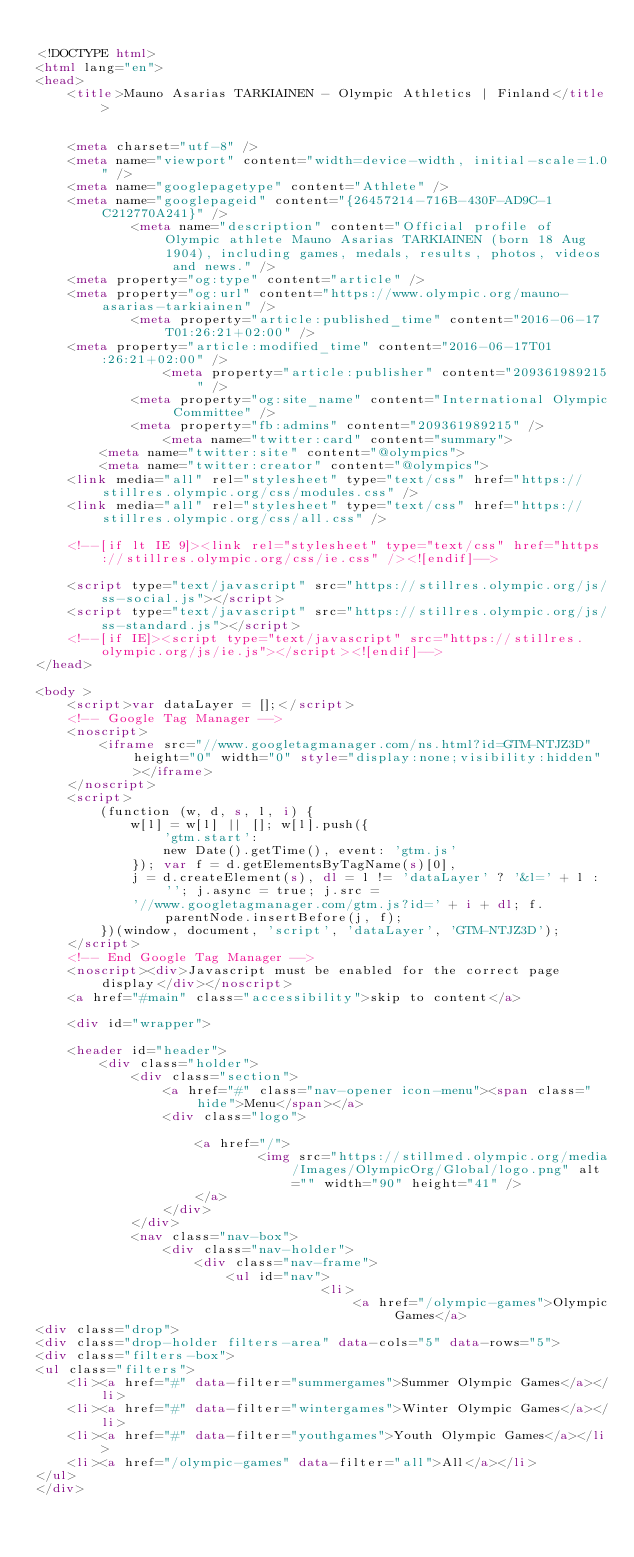Convert code to text. <code><loc_0><loc_0><loc_500><loc_500><_HTML_>
<!DOCTYPE html>
<html lang="en">
<head>
    <title>Mauno Asarias TARKIAINEN - Olympic Athletics | Finland</title>

    
    <meta charset="utf-8" />
    <meta name="viewport" content="width=device-width, initial-scale=1.0" />
    <meta name="googlepagetype" content="Athlete" />
    <meta name="googlepageid" content="{26457214-716B-430F-AD9C-1C212770A241}" />
            <meta name="description" content="Official profile of Olympic athlete Mauno Asarias TARKIAINEN (born 18 Aug 1904), including games, medals, results, photos, videos and news." />
    <meta property="og:type" content="article" />
    <meta property="og:url" content="https://www.olympic.org/mauno-asarias-tarkiainen" />
            <meta property="article:published_time" content="2016-06-17T01:26:21+02:00" />
    <meta property="article:modified_time" content="2016-06-17T01:26:21+02:00" />
                <meta property="article:publisher" content="209361989215" />
            <meta property="og:site_name" content="International Olympic Committee" />
            <meta property="fb:admins" content="209361989215" />
                <meta name="twitter:card" content="summary">
        <meta name="twitter:site" content="@olympics">
        <meta name="twitter:creator" content="@olympics">
    <link media="all" rel="stylesheet" type="text/css" href="https://stillres.olympic.org/css/modules.css" />
    <link media="all" rel="stylesheet" type="text/css" href="https://stillres.olympic.org/css/all.css" />
    
    <!--[if lt IE 9]><link rel="stylesheet" type="text/css" href="https://stillres.olympic.org/css/ie.css" /><![endif]-->
    
    <script type="text/javascript" src="https://stillres.olympic.org/js/ss-social.js"></script>
    <script type="text/javascript" src="https://stillres.olympic.org/js/ss-standard.js"></script>
    <!--[if IE]><script type="text/javascript" src="https://stillres.olympic.org/js/ie.js"></script><![endif]-->
</head>

<body >
    <script>var dataLayer = [];</script>
    <!-- Google Tag Manager -->
    <noscript>
        <iframe src="//www.googletagmanager.com/ns.html?id=GTM-NTJZ3D" height="0" width="0" style="display:none;visibility:hidden"></iframe>
    </noscript>
    <script>
        (function (w, d, s, l, i) {
            w[l] = w[l] || []; w[l].push({
                'gtm.start':
                new Date().getTime(), event: 'gtm.js'
            }); var f = d.getElementsByTagName(s)[0],
            j = d.createElement(s), dl = l != 'dataLayer' ? '&l=' + l : ''; j.async = true; j.src =
            '//www.googletagmanager.com/gtm.js?id=' + i + dl; f.parentNode.insertBefore(j, f);
        })(window, document, 'script', 'dataLayer', 'GTM-NTJZ3D');
    </script>
    <!-- End Google Tag Manager -->
    <noscript><div>Javascript must be enabled for the correct page display</div></noscript>
    <a href="#main" class="accessibility">skip to content</a>
    
    <div id="wrapper">
        
    <header id="header">
        <div class="holder">
            <div class="section">
                <a href="#" class="nav-opener icon-menu"><span class="hide">Menu</span></a>
                <div class="logo">

                    <a href="/">
                            <img src="https://stillmed.olympic.org/media/Images/OlympicOrg/Global/logo.png" alt="" width="90" height="41" />
                    </a>
                </div>
            </div>
            <nav class="nav-box">
                <div class="nav-holder">
                    <div class="nav-frame">
                        <ul id="nav">
                                    <li>
                                        <a href="/olympic-games">Olympic Games</a>
<div class="drop">
<div class="drop-holder filters-area" data-cols="5" data-rows="5">
<div class="filters-box">
<ul class="filters">
    <li><a href="#" data-filter="summergames">Summer Olympic Games</a></li>
    <li><a href="#" data-filter="wintergames">Winter Olympic Games</a></li>
    <li><a href="#" data-filter="youthgames">Youth Olympic Games</a></li>
    <li><a href="/olympic-games" data-filter="all">All</a></li>
</ul>
</div></code> 